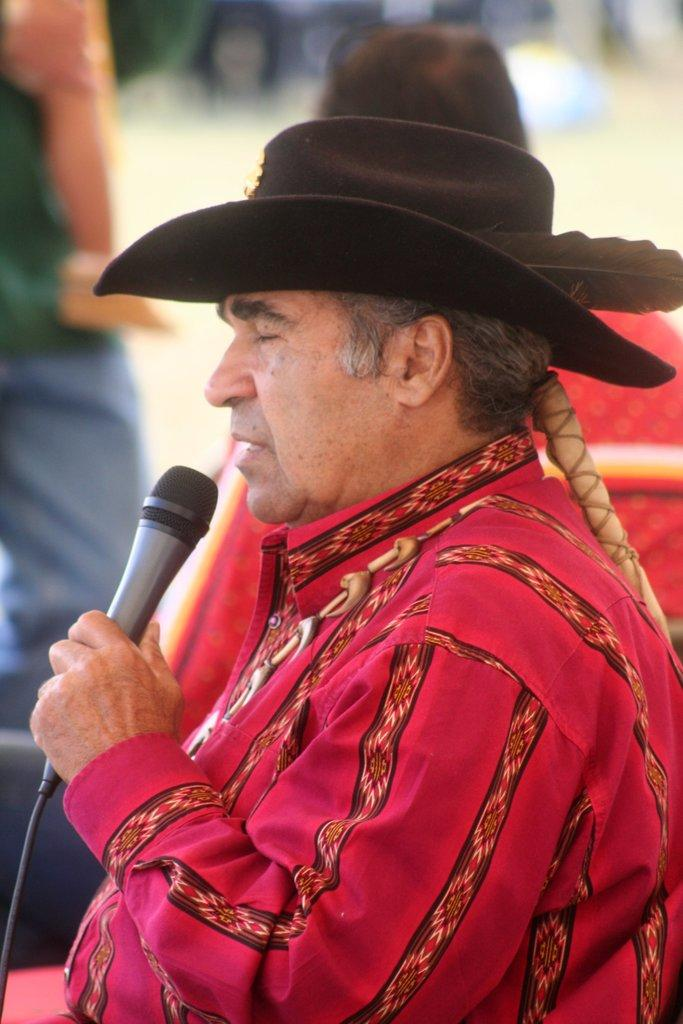Who is the main subject in the image? There is a man in the image. What is the man holding in his hand? The man is holding a mic in his hand. What accessory is the man wearing on his head? The man is wearing a hat on his head. What type of drug is the man using in the image? There is no drug present in the image; the man is holding a mic in his hand. Is there a mailbox visible in the image? No, there is no mailbox present in the image. 